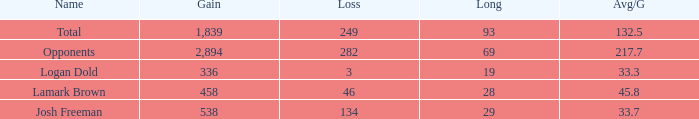How much Gain has a Long of 29, and an Avg/G smaller than 33.7? 0.0. 